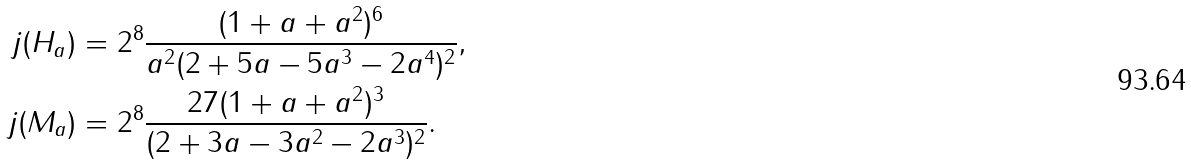<formula> <loc_0><loc_0><loc_500><loc_500>j ( H _ { a } ) & = 2 ^ { 8 } \frac { ( 1 + a + a ^ { 2 } ) ^ { 6 } } { a ^ { 2 } ( 2 + 5 a - 5 a ^ { 3 } - 2 a ^ { 4 } ) ^ { 2 } } , \\ j ( M _ { a } ) & = 2 ^ { 8 } \frac { 2 7 ( 1 + a + a ^ { 2 } ) ^ { 3 } } { ( 2 + 3 a - 3 a ^ { 2 } - 2 a ^ { 3 } ) ^ { 2 } } .</formula> 